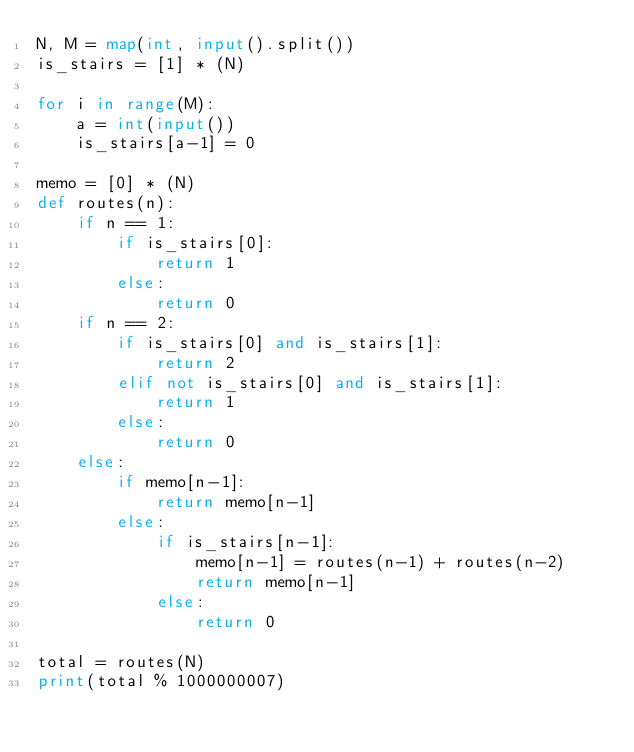<code> <loc_0><loc_0><loc_500><loc_500><_Python_>N, M = map(int, input().split())
is_stairs = [1] * (N)

for i in range(M):
    a = int(input())
    is_stairs[a-1] = 0

memo = [0] * (N)
def routes(n):
    if n == 1:
        if is_stairs[0]:
            return 1
        else:
            return 0
    if n == 2:
        if is_stairs[0] and is_stairs[1]:
            return 2
        elif not is_stairs[0] and is_stairs[1]:
            return 1
        else:
            return 0
    else:
        if memo[n-1]:
            return memo[n-1]
        else:
            if is_stairs[n-1]:
                memo[n-1] = routes(n-1) + routes(n-2)
                return memo[n-1]
            else:
                return 0

total = routes(N)
print(total % 1000000007)
</code> 